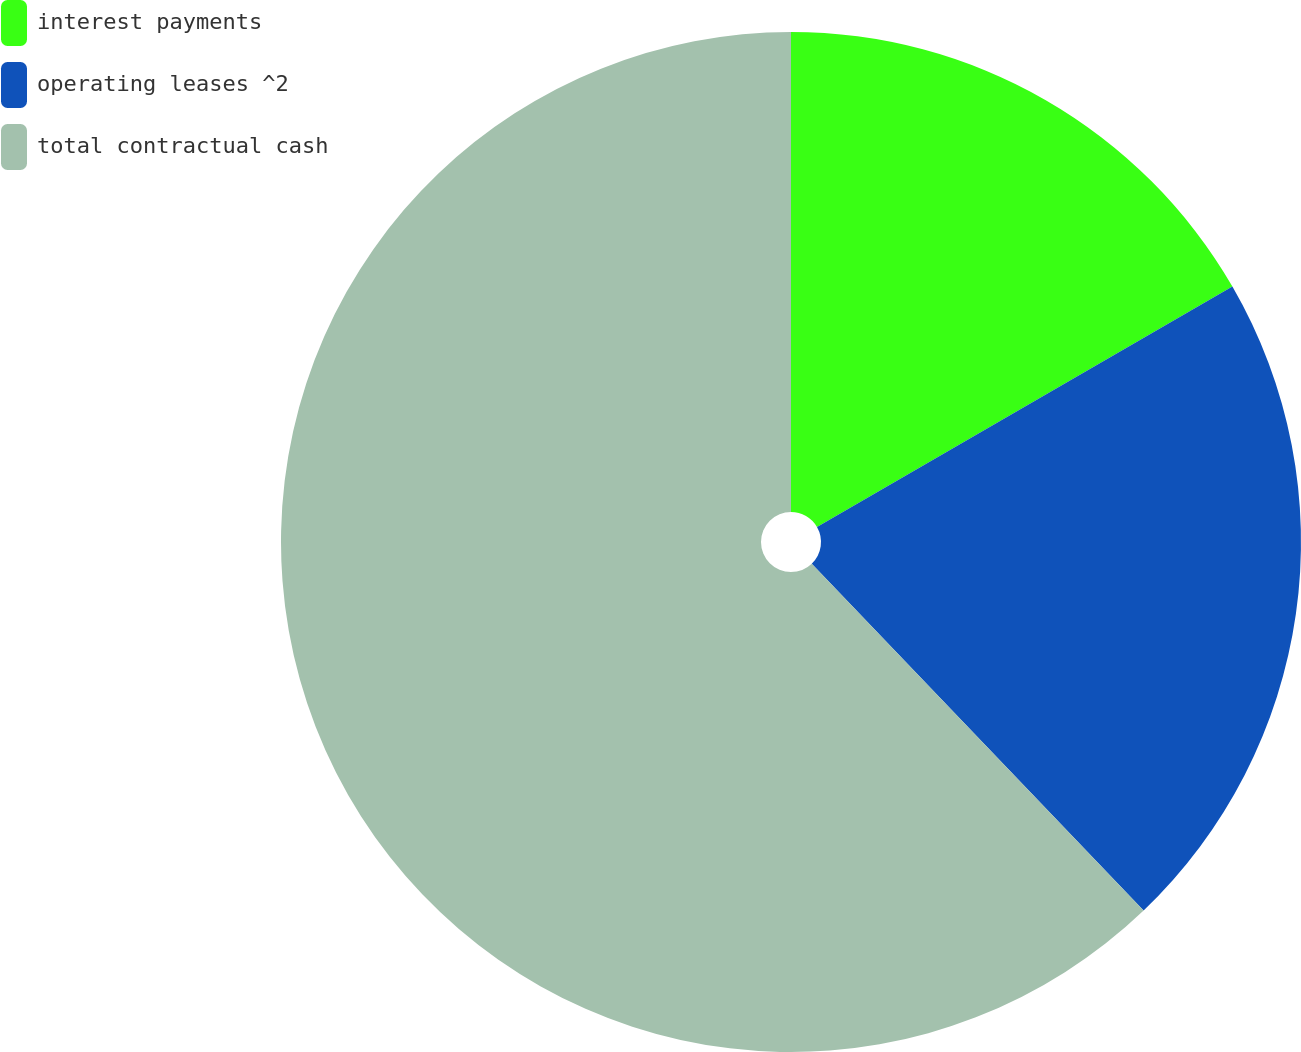<chart> <loc_0><loc_0><loc_500><loc_500><pie_chart><fcel>interest payments<fcel>operating leases ^2<fcel>total contractual cash<nl><fcel>16.65%<fcel>21.2%<fcel>62.15%<nl></chart> 